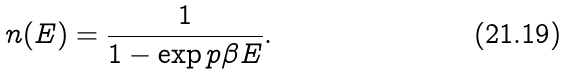<formula> <loc_0><loc_0><loc_500><loc_500>n ( E ) = \frac { 1 } { 1 - \exp p { \beta E } } .</formula> 